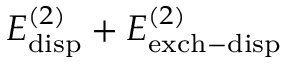Convert formula to latex. <formula><loc_0><loc_0><loc_500><loc_500>E _ { d i s p } ^ { ( 2 ) } + E _ { e x c h - d i s p } ^ { ( 2 ) }</formula> 